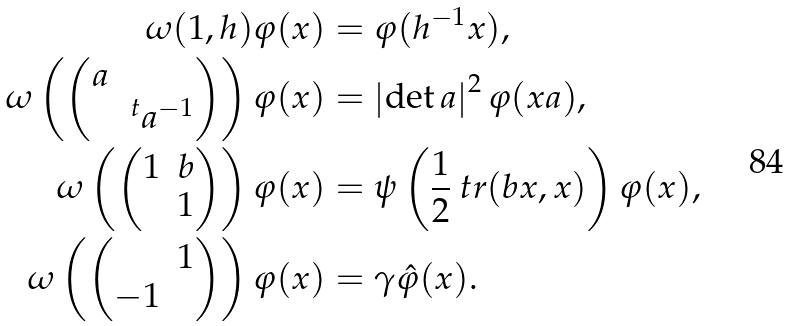<formula> <loc_0><loc_0><loc_500><loc_500>\omega ( 1 , h ) \varphi ( x ) & = \varphi ( h ^ { - 1 } x ) , \\ \omega \left ( \begin{pmatrix} a \\ & \, ^ { t } a ^ { - 1 } \end{pmatrix} \right ) \varphi ( x ) & = \left | \det a \right | ^ { 2 } \varphi ( x a ) , \\ \omega \left ( \begin{pmatrix} 1 & b \\ & 1 \end{pmatrix} \right ) \varphi ( x ) & = \psi \left ( \frac { 1 } { 2 } \ t r ( b x , x ) \right ) \varphi ( x ) , \\ \omega \left ( \begin{pmatrix} & 1 \\ - 1 \end{pmatrix} \right ) \varphi ( x ) & = \gamma \hat { \varphi } ( x ) .</formula> 